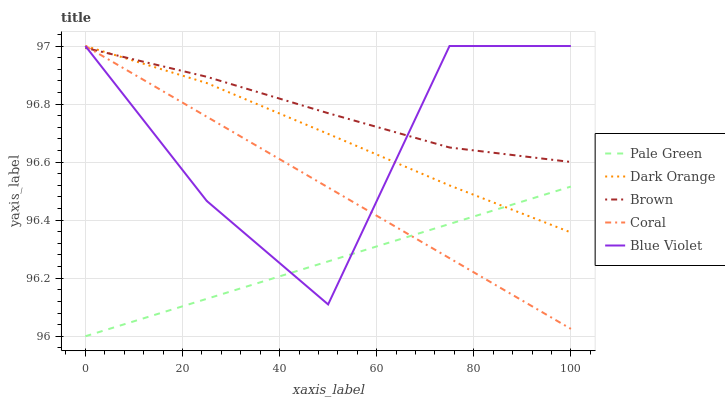Does Pale Green have the minimum area under the curve?
Answer yes or no. Yes. Does Brown have the maximum area under the curve?
Answer yes or no. Yes. Does Coral have the minimum area under the curve?
Answer yes or no. No. Does Coral have the maximum area under the curve?
Answer yes or no. No. Is Coral the smoothest?
Answer yes or no. Yes. Is Blue Violet the roughest?
Answer yes or no. Yes. Is Pale Green the smoothest?
Answer yes or no. No. Is Pale Green the roughest?
Answer yes or no. No. Does Pale Green have the lowest value?
Answer yes or no. Yes. Does Coral have the lowest value?
Answer yes or no. No. Does Blue Violet have the highest value?
Answer yes or no. Yes. Does Pale Green have the highest value?
Answer yes or no. No. Is Pale Green less than Brown?
Answer yes or no. Yes. Is Brown greater than Pale Green?
Answer yes or no. Yes. Does Blue Violet intersect Dark Orange?
Answer yes or no. Yes. Is Blue Violet less than Dark Orange?
Answer yes or no. No. Is Blue Violet greater than Dark Orange?
Answer yes or no. No. Does Pale Green intersect Brown?
Answer yes or no. No. 